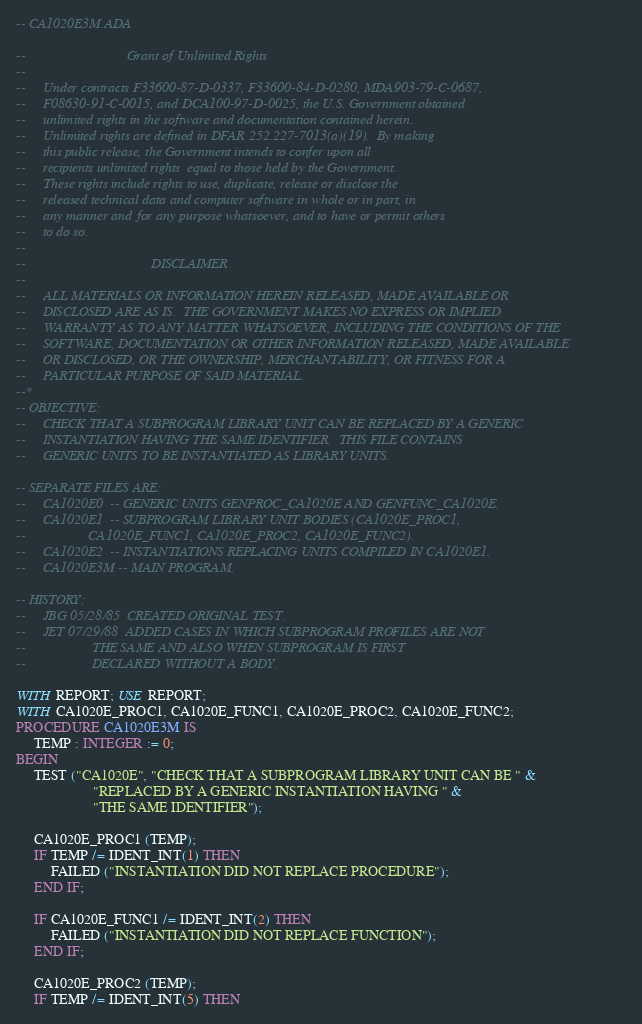Convert code to text. <code><loc_0><loc_0><loc_500><loc_500><_Ada_>-- CA1020E3M.ADA

--                             Grant of Unlimited Rights
--
--     Under contracts F33600-87-D-0337, F33600-84-D-0280, MDA903-79-C-0687,
--     F08630-91-C-0015, and DCA100-97-D-0025, the U.S. Government obtained 
--     unlimited rights in the software and documentation contained herein.
--     Unlimited rights are defined in DFAR 252.227-7013(a)(19).  By making 
--     this public release, the Government intends to confer upon all 
--     recipients unlimited rights  equal to those held by the Government.  
--     These rights include rights to use, duplicate, release or disclose the 
--     released technical data and computer software in whole or in part, in 
--     any manner and for any purpose whatsoever, and to have or permit others 
--     to do so.
--
--                                    DISCLAIMER
--
--     ALL MATERIALS OR INFORMATION HEREIN RELEASED, MADE AVAILABLE OR
--     DISCLOSED ARE AS IS.  THE GOVERNMENT MAKES NO EXPRESS OR IMPLIED 
--     WARRANTY AS TO ANY MATTER WHATSOEVER, INCLUDING THE CONDITIONS OF THE
--     SOFTWARE, DOCUMENTATION OR OTHER INFORMATION RELEASED, MADE AVAILABLE 
--     OR DISCLOSED, OR THE OWNERSHIP, MERCHANTABILITY, OR FITNESS FOR A
--     PARTICULAR PURPOSE OF SAID MATERIAL.
--*
-- OBJECTIVE:
--     CHECK THAT A SUBPROGRAM LIBRARY UNIT CAN BE REPLACED BY A GENERIC
--     INSTANTIATION HAVING THE SAME IDENTIFIER.  THIS FILE CONTAINS
--     GENERIC UNITS TO BE INSTANTIATED AS LIBRARY UNITS.

-- SEPARATE FILES ARE:
--     CA1020E0  -- GENERIC UNITS GENPROC_CA1020E AND GENFUNC_CA1020E.
--     CA1020E1  -- SUBPROGRAM LIBRARY UNIT BODIES (CA1020E_PROC1,
--                  CA1020E_FUNC1, CA1020E_PROC2, CA1020E_FUNC2).
--     CA1020E2  -- INSTANTIATIONS REPLACING UNITS COMPILED IN CA1020E1.
--     CA1020E3M -- MAIN PROGRAM.

-- HISTORY:
--     JBG 05/28/85  CREATED ORIGINAL TEST.
--     JET 07/29/88  ADDED CASES IN WHICH SUBPROGRAM PROFILES ARE NOT
--                   THE SAME AND ALSO WHEN SUBPROGRAM IS FIRST
--                   DECLARED WITHOUT A BODY.

WITH REPORT; USE REPORT;
WITH CA1020E_PROC1, CA1020E_FUNC1, CA1020E_PROC2, CA1020E_FUNC2;
PROCEDURE CA1020E3M IS
     TEMP : INTEGER := 0;
BEGIN
     TEST ("CA1020E", "CHECK THAT A SUBPROGRAM LIBRARY UNIT CAN BE " &
                      "REPLACED BY A GENERIC INSTANTIATION HAVING " &
                      "THE SAME IDENTIFIER");

     CA1020E_PROC1 (TEMP);
     IF TEMP /= IDENT_INT(1) THEN
          FAILED ("INSTANTIATION DID NOT REPLACE PROCEDURE");
     END IF;

     IF CA1020E_FUNC1 /= IDENT_INT(2) THEN
          FAILED ("INSTANTIATION DID NOT REPLACE FUNCTION");
     END IF;

     CA1020E_PROC2 (TEMP);
     IF TEMP /= IDENT_INT(5) THEN</code> 